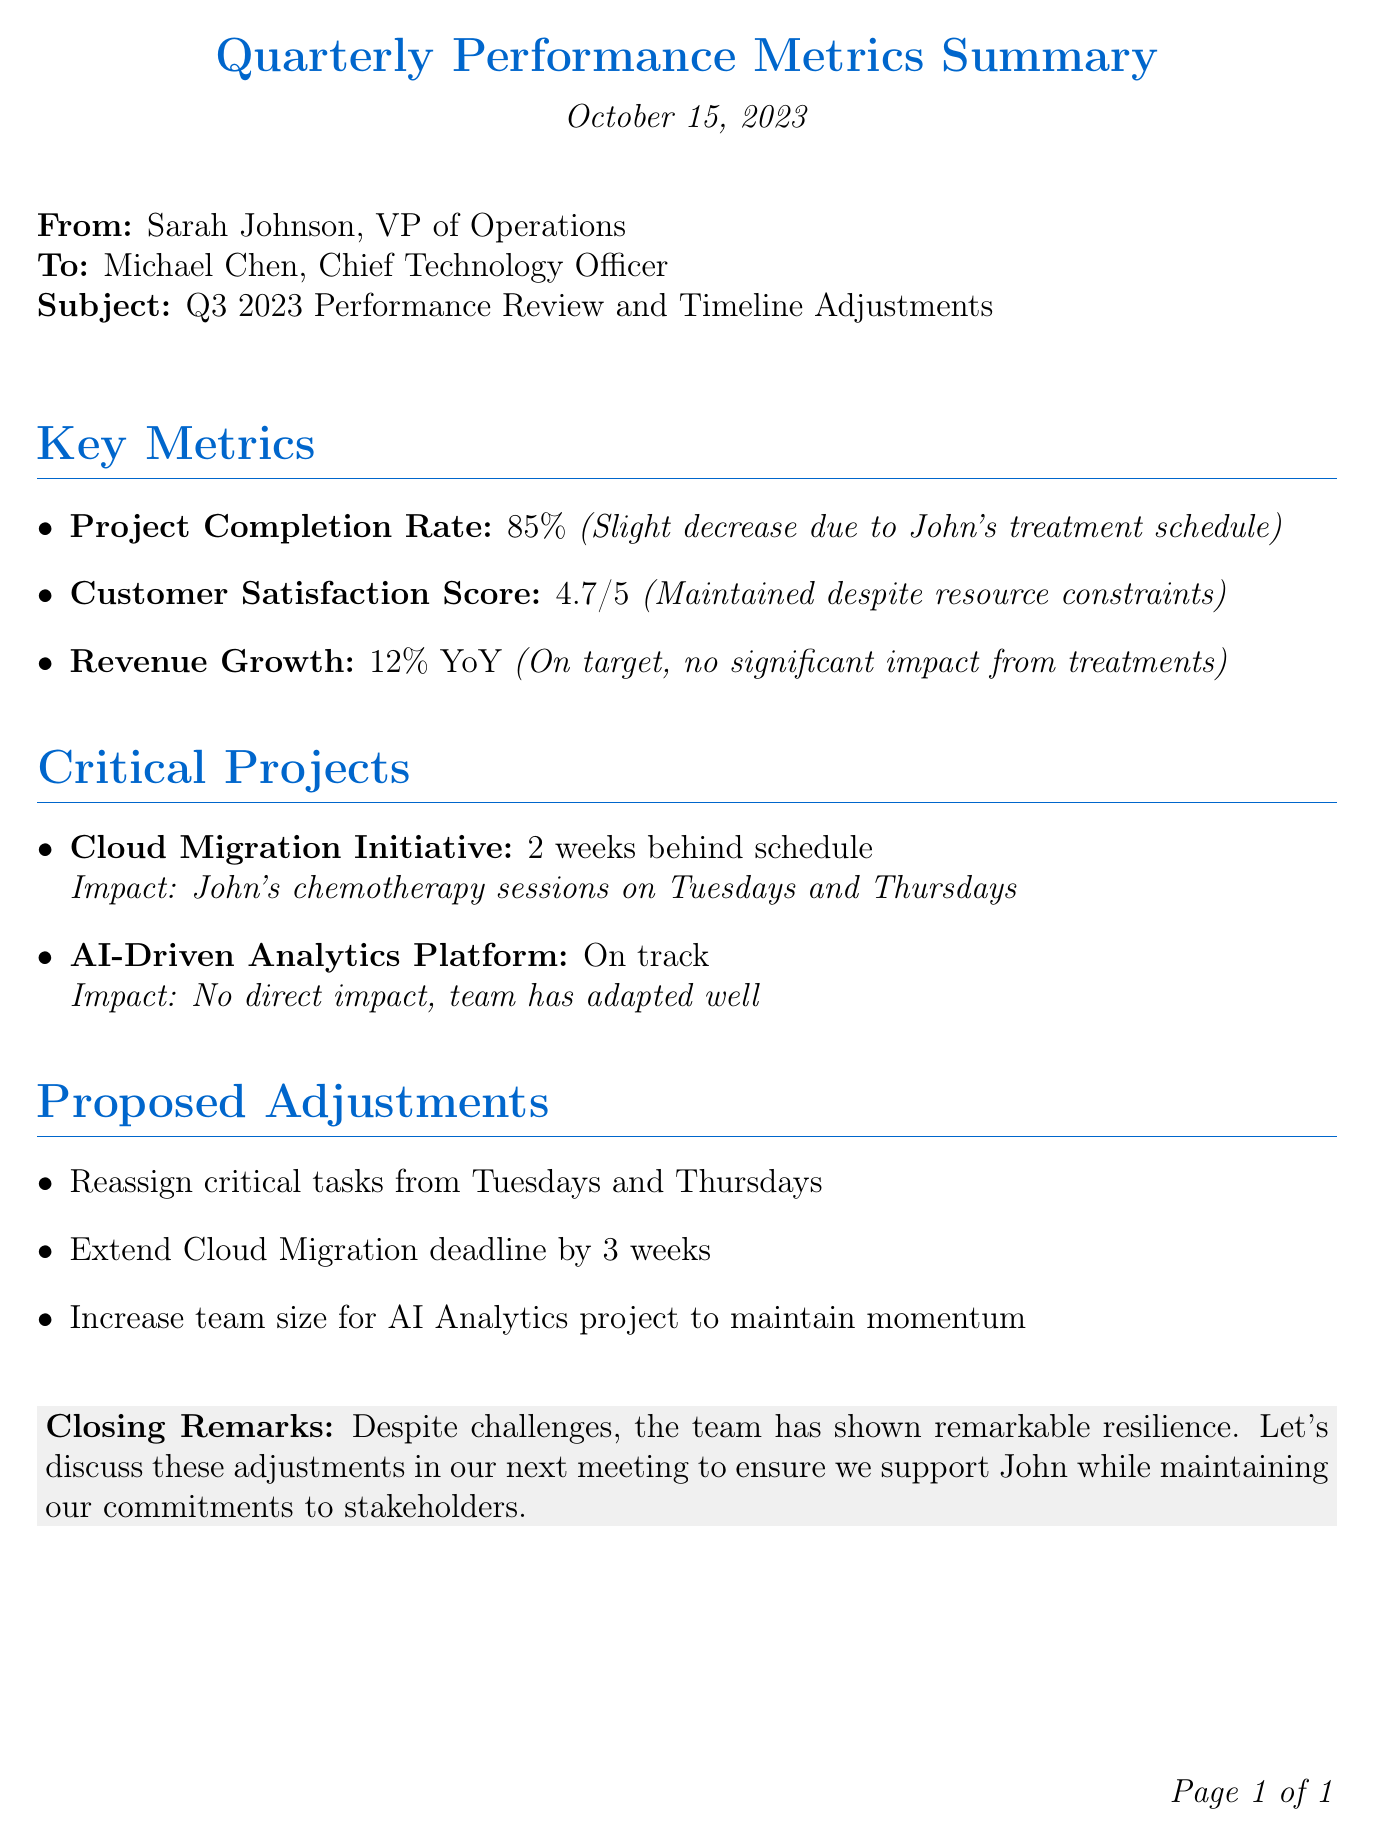What is the project completion rate? The project completion rate is specifically noted in the document as 85%.
Answer: 85% Who is the sender of the document? The sender of the document is Sarah Johnson, VP of Operations.
Answer: Sarah Johnson What is the customer satisfaction score? The customer satisfaction score listed in the document is 4.7 out of 5.
Answer: 4.7/5 Which project is behind schedule and by how many weeks? The project that is behind schedule is the Cloud Migration Initiative, and it is noted to be 2 weeks behind schedule.
Answer: 2 weeks What days are affected by John's treatment schedule? The days affected by John's treatment schedule are Tuesdays and Thursdays.
Answer: Tuesdays and Thursdays What adjustment is proposed for the Cloud Migration deadline? The proposed adjustment for the Cloud Migration deadline is an extension by 3 weeks.
Answer: 3 weeks What was the year-over-year revenue growth? The year-over-year revenue growth mentioned in the document is 12%.
Answer: 12% Is the AI-Driven Analytics Platform on track? The document states that the AI-Driven Analytics Platform is on track with no direct impacts.
Answer: On track What does the closing remark suggest about the team's performance? The closing remark suggests that despite challenges, the team has shown remarkable resilience.
Answer: Remarkable resilience 